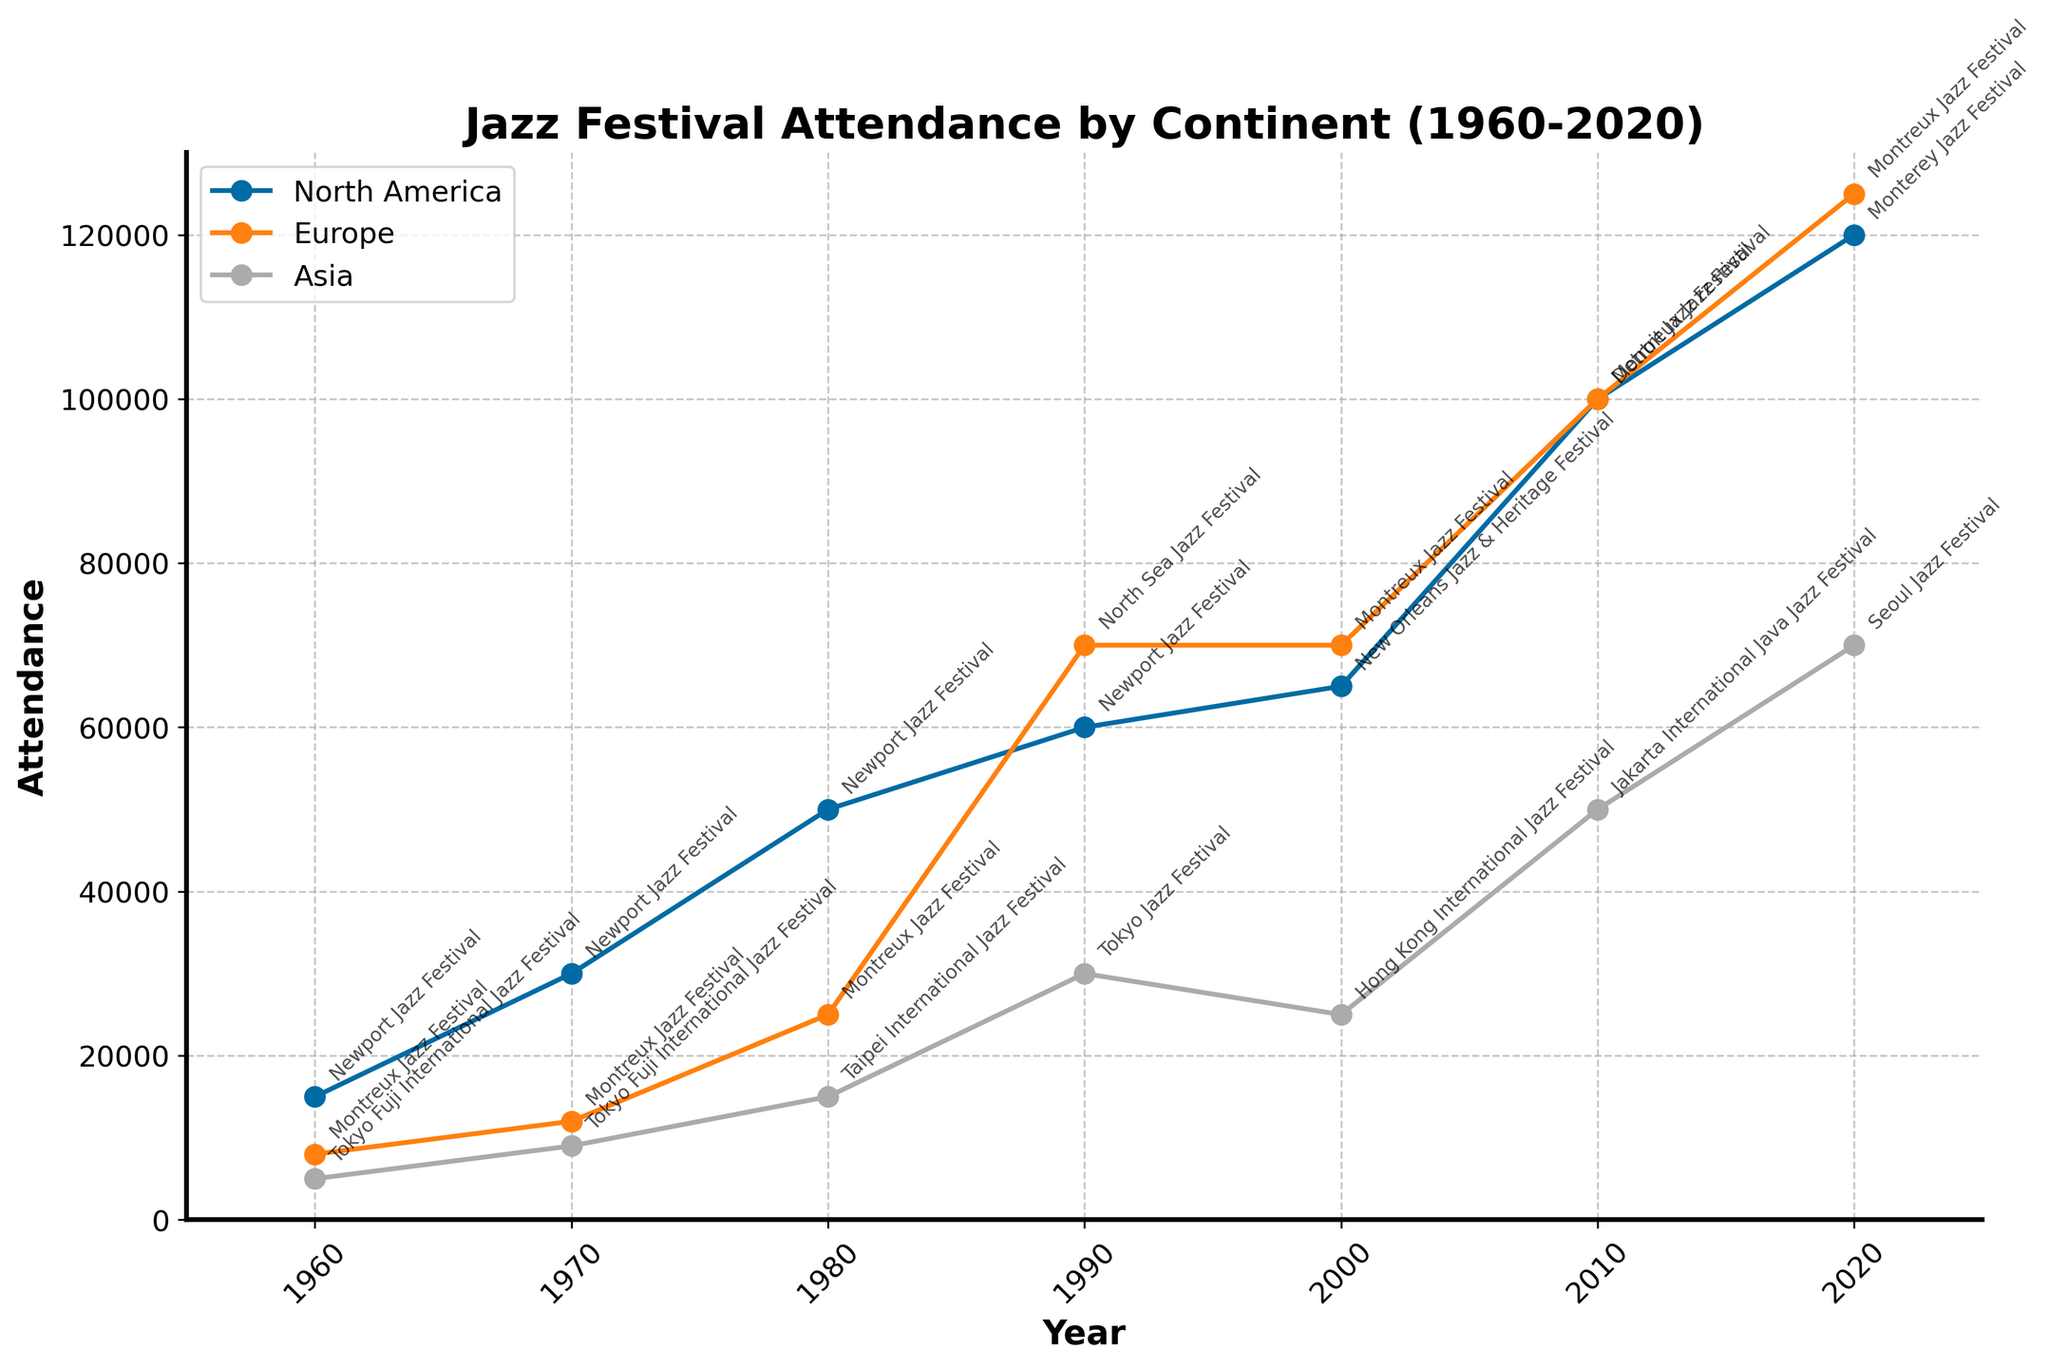What is the title of the time series plot? The title is prominently displayed at the top of the plot. read the text to find it.
Answer: Jazz Festival Attendance by Continent (1960-2020) Which continent had the highest festival attendance in 2020? Look at the attendance values for each continent in 2020 and identify the highest value.
Answer: Europe How did the attendance of North American festivals change from 1960 to 2020? Note the attendance values for North America in both 1960 and 2020 and calculate the difference.
Answer: Increased by 105,000 Among the years 1960, 1980, and 2000, which year had the highest attendance in Asia? Compare the attendance values for Asia in the years 1960, 1980, and 2000.
Answer: 2000 Which year saw the introduction of the highest attendance festival in Europe? Identify the year with the highest attendance in Europe and check the festival introduced that year.
Answer: 2010, Montreux Jazz Festival What was the average attendance for European festivals across all years shown? Add the attendance values for Europe for each year and divide by the number of data points for Europe.
Answer: 58,333 In which year did Asia see the greatest increase in attendance compared to the previous decade? Calculate the change in attendance for Asia between each decade and identify the maximum increase.
Answer: 1990 How many festivals in total are labeled in the year 2010? Count the number of festivals annotated on the plot for the year 2010.
Answer: Three Across all continents, which decade had the most significant overall increase in attendance from the previous decade? Calculate the total attendance for each decade for all continents and find the decade with the highest increase from its predecessor.
Answer: 2000-2010 How does festival attendance in Europe in 2020 compare to that in 1980? Compare the attendance values for European festivals in both 2020 and 1980 and compute the difference.
Answer: Increased by 100,000 